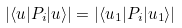<formula> <loc_0><loc_0><loc_500><loc_500>| \langle u | P _ { i } | u \rangle | = | \langle u _ { 1 } | P _ { i } | u _ { 1 } \rangle |</formula> 